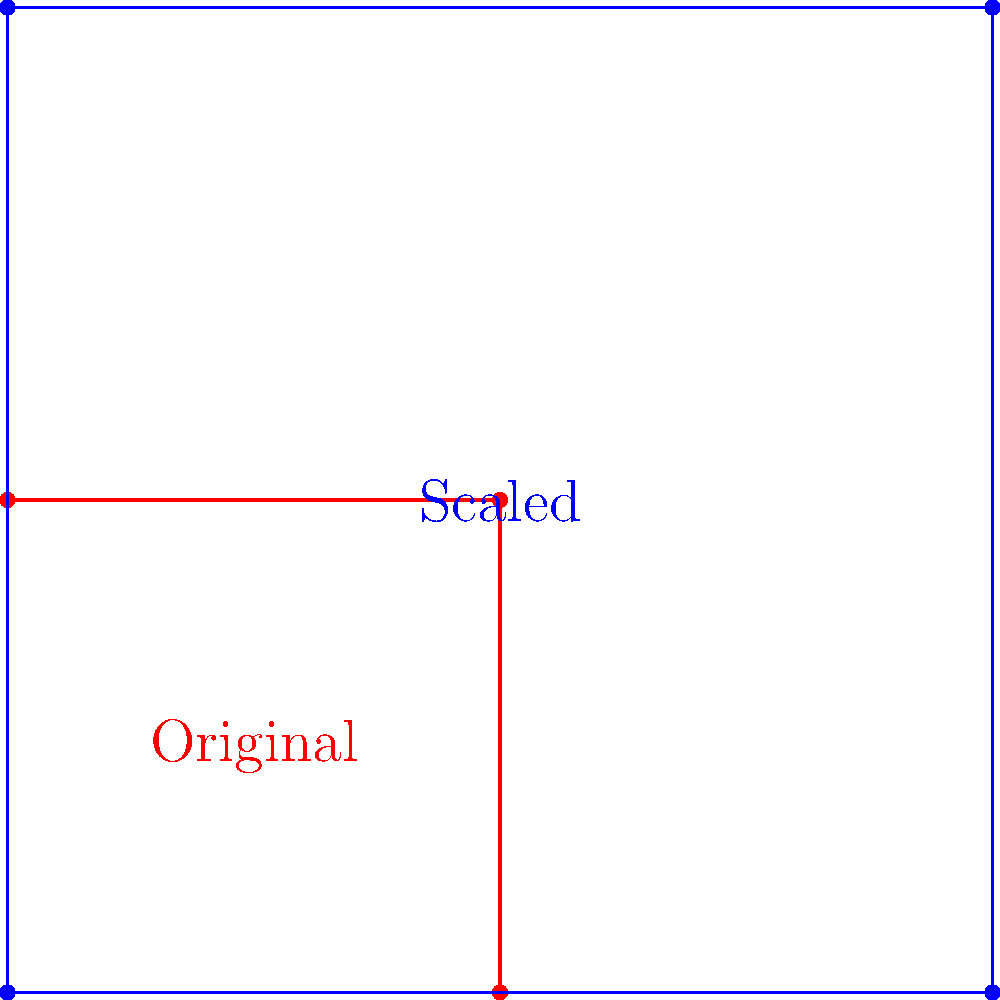In your astrological chart, you've arranged four zodiac symbols in a square formation. To enhance visibility, you decide to scale up this arrangement while maintaining the relative positions. If the original square had a side length of 1 unit and the scaled version has a side length of 2 units, what is the scale factor applied to the original configuration? To determine the scale factor, we need to compare the dimensions of the original and scaled configurations:

1. Original square side length: 1 unit
2. Scaled square side length: 2 units

The scale factor is the ratio of the new size to the original size. We can calculate this as follows:

$$ \text{Scale Factor} = \frac{\text{New Size}}{\text{Original Size}} = \frac{2}{1} = 2 $$

This means that each dimension of the original square has been multiplied by 2 to obtain the scaled version. 

To verify:
- Original area: $1 \times 1 = 1$ square unit
- Scaled area: $2 \times 2 = 4$ square units

The area has increased by a factor of $2^2 = 4$, which is consistent with a linear scale factor of 2.

This scaling preserves the relative positions of the zodiac symbols while doubling their distance from each other and from the origin.
Answer: 2 